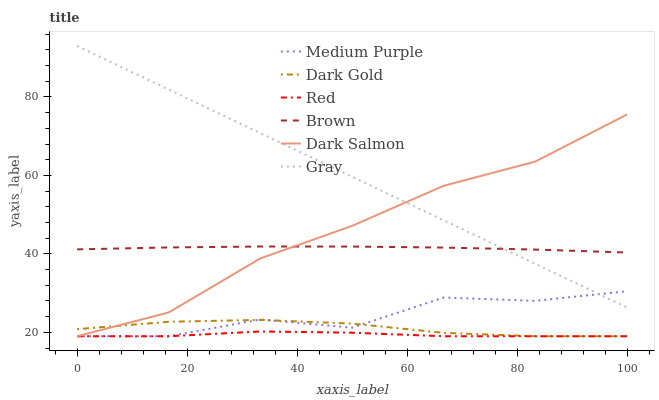Does Red have the minimum area under the curve?
Answer yes or no. Yes. Does Gray have the maximum area under the curve?
Answer yes or no. Yes. Does Dark Gold have the minimum area under the curve?
Answer yes or no. No. Does Dark Gold have the maximum area under the curve?
Answer yes or no. No. Is Gray the smoothest?
Answer yes or no. Yes. Is Medium Purple the roughest?
Answer yes or no. Yes. Is Dark Gold the smoothest?
Answer yes or no. No. Is Dark Gold the roughest?
Answer yes or no. No. Does Dark Gold have the lowest value?
Answer yes or no. Yes. Does Gray have the lowest value?
Answer yes or no. No. Does Gray have the highest value?
Answer yes or no. Yes. Does Dark Gold have the highest value?
Answer yes or no. No. Is Red less than Brown?
Answer yes or no. Yes. Is Brown greater than Dark Gold?
Answer yes or no. Yes. Does Dark Gold intersect Red?
Answer yes or no. Yes. Is Dark Gold less than Red?
Answer yes or no. No. Is Dark Gold greater than Red?
Answer yes or no. No. Does Red intersect Brown?
Answer yes or no. No. 